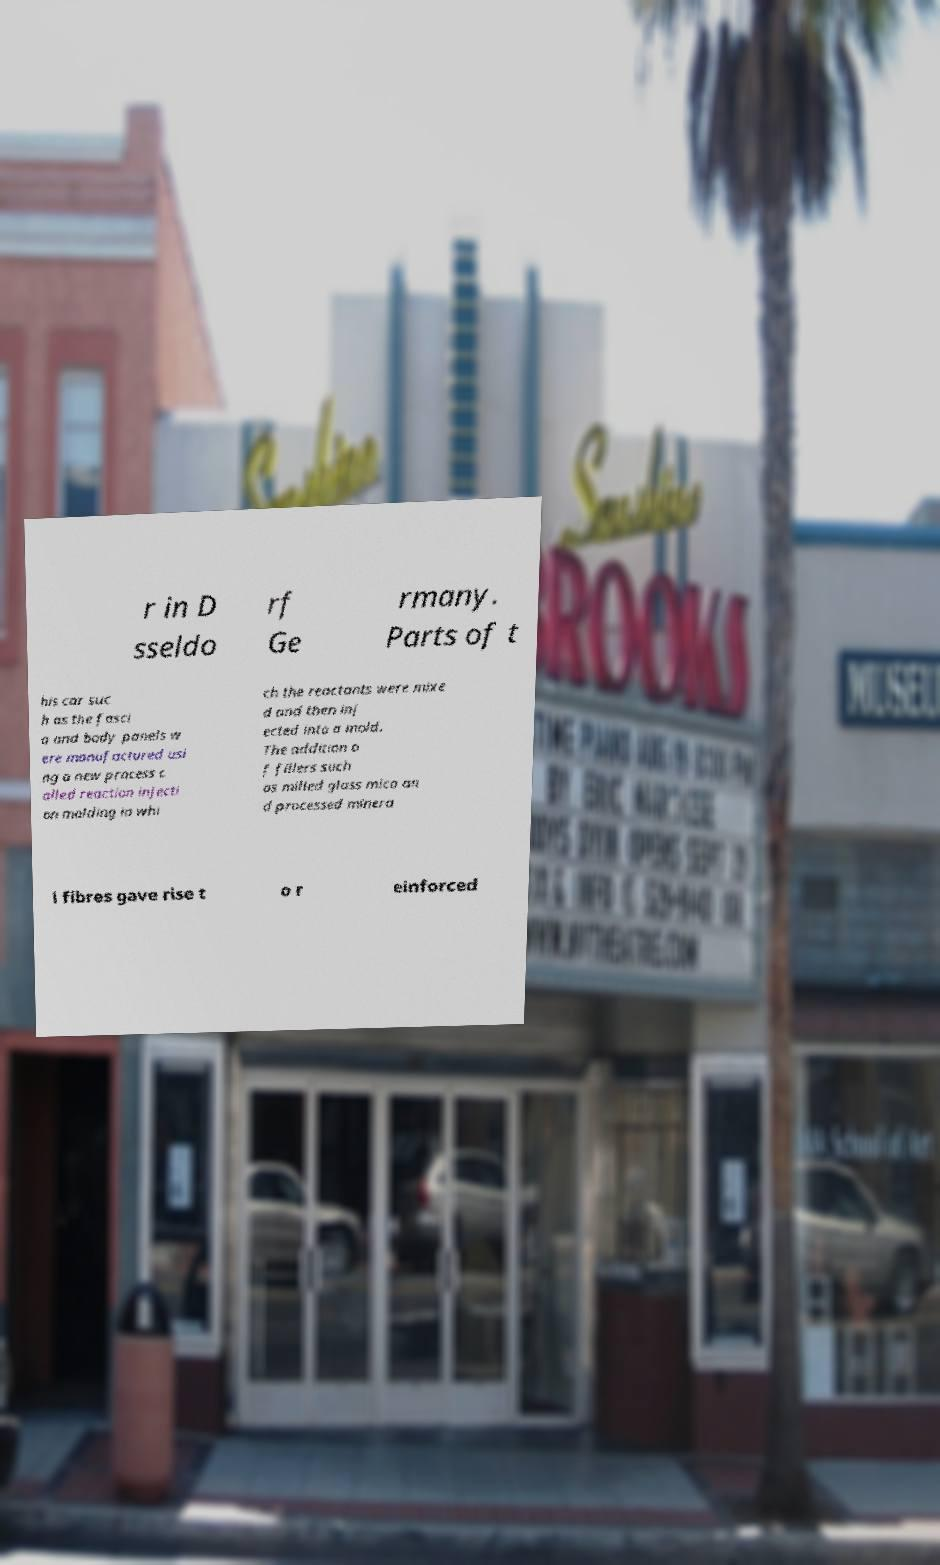I need the written content from this picture converted into text. Can you do that? r in D sseldo rf Ge rmany. Parts of t his car suc h as the fasci a and body panels w ere manufactured usi ng a new process c alled reaction injecti on molding in whi ch the reactants were mixe d and then inj ected into a mold. The addition o f fillers such as milled glass mica an d processed minera l fibres gave rise t o r einforced 